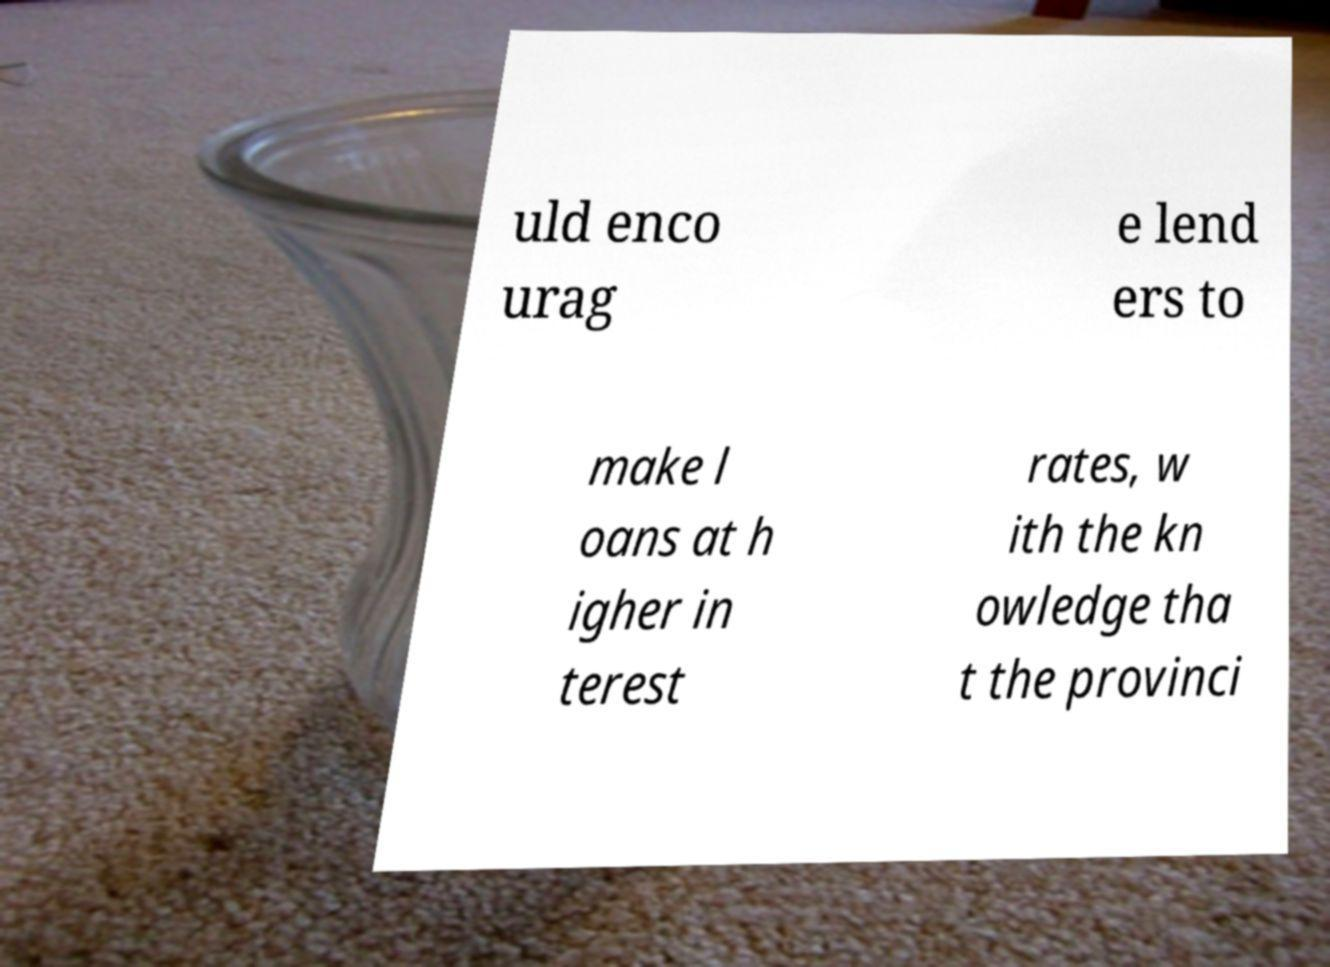Can you read and provide the text displayed in the image?This photo seems to have some interesting text. Can you extract and type it out for me? uld enco urag e lend ers to make l oans at h igher in terest rates, w ith the kn owledge tha t the provinci 